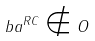<formula> <loc_0><loc_0><loc_500><loc_500>b a ^ { R C } \notin O</formula> 